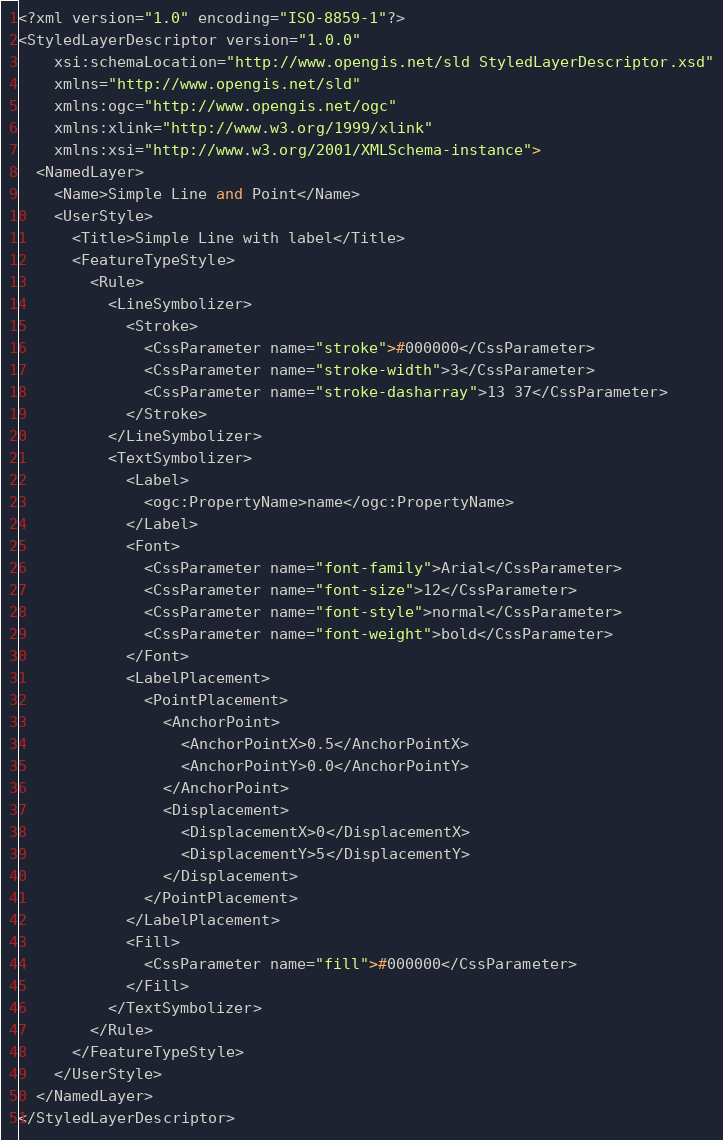Convert code to text. <code><loc_0><loc_0><loc_500><loc_500><_Scheme_><?xml version="1.0" encoding="ISO-8859-1"?>
<StyledLayerDescriptor version="1.0.0"
    xsi:schemaLocation="http://www.opengis.net/sld StyledLayerDescriptor.xsd"
    xmlns="http://www.opengis.net/sld"
    xmlns:ogc="http://www.opengis.net/ogc"
    xmlns:xlink="http://www.w3.org/1999/xlink"
    xmlns:xsi="http://www.w3.org/2001/XMLSchema-instance">
  <NamedLayer>
    <Name>Simple Line and Point</Name>
    <UserStyle>
      <Title>Simple Line with label</Title>
      <FeatureTypeStyle>
        <Rule>
          <LineSymbolizer>
            <Stroke>
              <CssParameter name="stroke">#000000</CssParameter>
              <CssParameter name="stroke-width">3</CssParameter>
              <CssParameter name="stroke-dasharray">13 37</CssParameter>
            </Stroke>
          </LineSymbolizer>
          <TextSymbolizer>
            <Label>
              <ogc:PropertyName>name</ogc:PropertyName>
            </Label>
            <Font>
              <CssParameter name="font-family">Arial</CssParameter>
              <CssParameter name="font-size">12</CssParameter>
              <CssParameter name="font-style">normal</CssParameter>
              <CssParameter name="font-weight">bold</CssParameter>
            </Font>
            <LabelPlacement>
              <PointPlacement>
                <AnchorPoint>
                  <AnchorPointX>0.5</AnchorPointX>
                  <AnchorPointY>0.0</AnchorPointY>
                </AnchorPoint>
                <Displacement>
                  <DisplacementX>0</DisplacementX>
                  <DisplacementY>5</DisplacementY>
                </Displacement>
              </PointPlacement>
            </LabelPlacement>
            <Fill>
              <CssParameter name="fill">#000000</CssParameter>
            </Fill>
          </TextSymbolizer>
        </Rule>
      </FeatureTypeStyle>
    </UserStyle>
  </NamedLayer>
</StyledLayerDescriptor>
</code> 